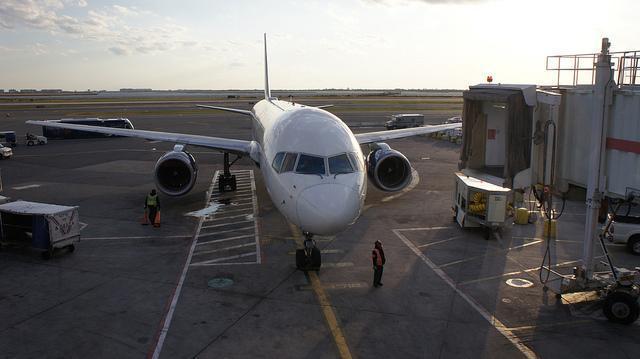How many men are carrying traffic cones?
Give a very brief answer. 1. How many bananas are in the picture?
Give a very brief answer. 0. 